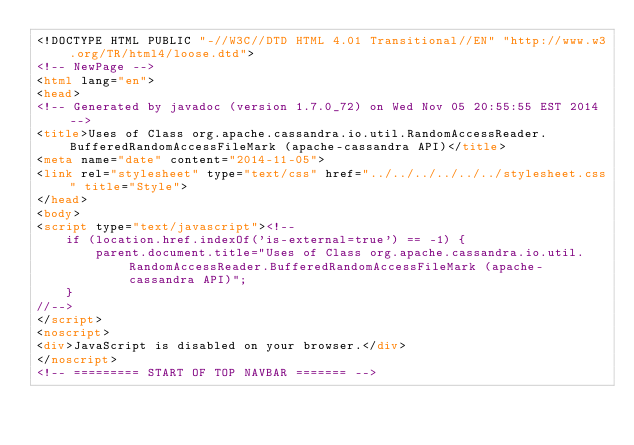Convert code to text. <code><loc_0><loc_0><loc_500><loc_500><_HTML_><!DOCTYPE HTML PUBLIC "-//W3C//DTD HTML 4.01 Transitional//EN" "http://www.w3.org/TR/html4/loose.dtd">
<!-- NewPage -->
<html lang="en">
<head>
<!-- Generated by javadoc (version 1.7.0_72) on Wed Nov 05 20:55:55 EST 2014 -->
<title>Uses of Class org.apache.cassandra.io.util.RandomAccessReader.BufferedRandomAccessFileMark (apache-cassandra API)</title>
<meta name="date" content="2014-11-05">
<link rel="stylesheet" type="text/css" href="../../../../../../stylesheet.css" title="Style">
</head>
<body>
<script type="text/javascript"><!--
    if (location.href.indexOf('is-external=true') == -1) {
        parent.document.title="Uses of Class org.apache.cassandra.io.util.RandomAccessReader.BufferedRandomAccessFileMark (apache-cassandra API)";
    }
//-->
</script>
<noscript>
<div>JavaScript is disabled on your browser.</div>
</noscript>
<!-- ========= START OF TOP NAVBAR ======= --></code> 